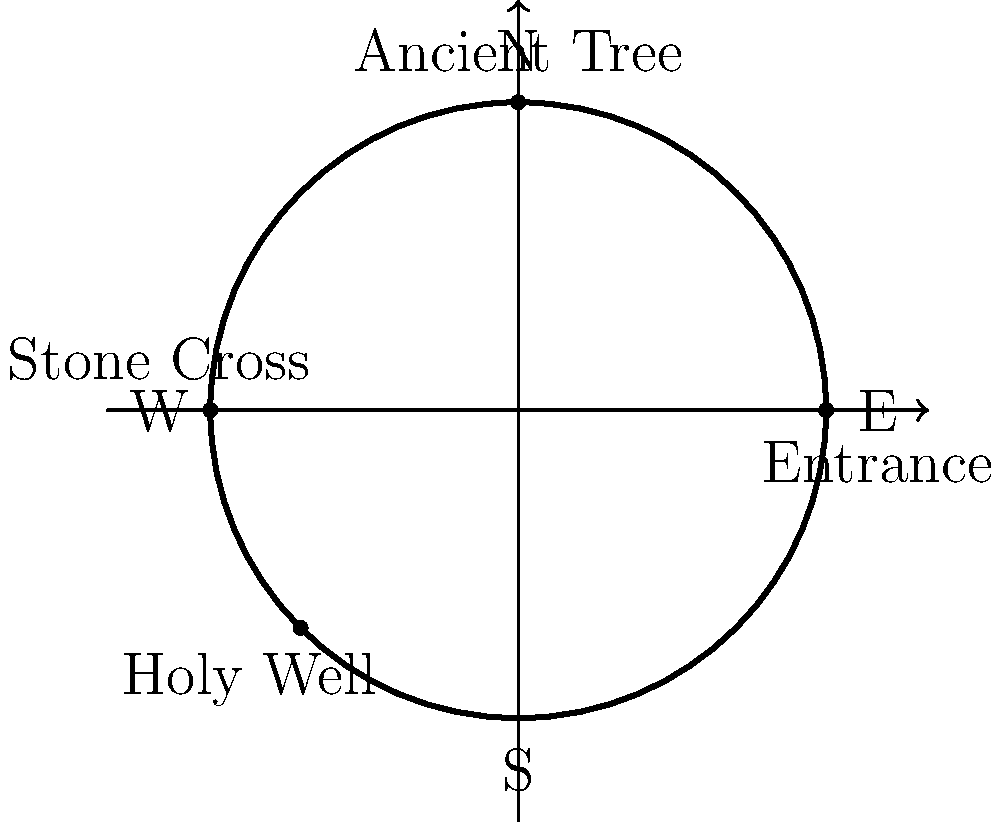The Timahoe Round Tower, a remarkable 12th-century structure in County Laois, is surrounded by various historical features. Using the polar coordinate system with the tower's center as the origin, which of the following statements accurately describes the location of the ancient tree in relation to the tower's entrance? To answer this question, let's follow these steps:

1. Understand the polar coordinate system:
   - The origin (0,0) is at the center of the tower.
   - The angle is measured counterclockwise from the positive x-axis.
   - The radius is the distance from the origin.

2. Identify key points:
   - The entrance is located on the positive x-axis (east), so it's at (r, 0°).
   - The ancient tree is located at the top of the circle (north), so it's at (r, 90°).

3. Calculate the angle between the entrance and the tree:
   - The angle from the entrance to the tree is 90° counterclockwise.

4. Express the tree's location relative to the entrance:
   - The tree is located 90° counterclockwise from the entrance.
   - Both the entrance and the tree are on the circumference of the tower, so they have the same radius.

5. Formulate the answer in polar coordinates:
   - Relative to the entrance, the tree is at $$(r, 90°)$$ in polar coordinates.
Answer: $$(r, 90°)$$ 